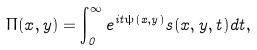<formula> <loc_0><loc_0><loc_500><loc_500>\Pi ( x , y ) = \int _ { 0 } ^ { \infty } e ^ { i t \psi ( x , y ) } s ( x , y , t ) d t ,</formula> 